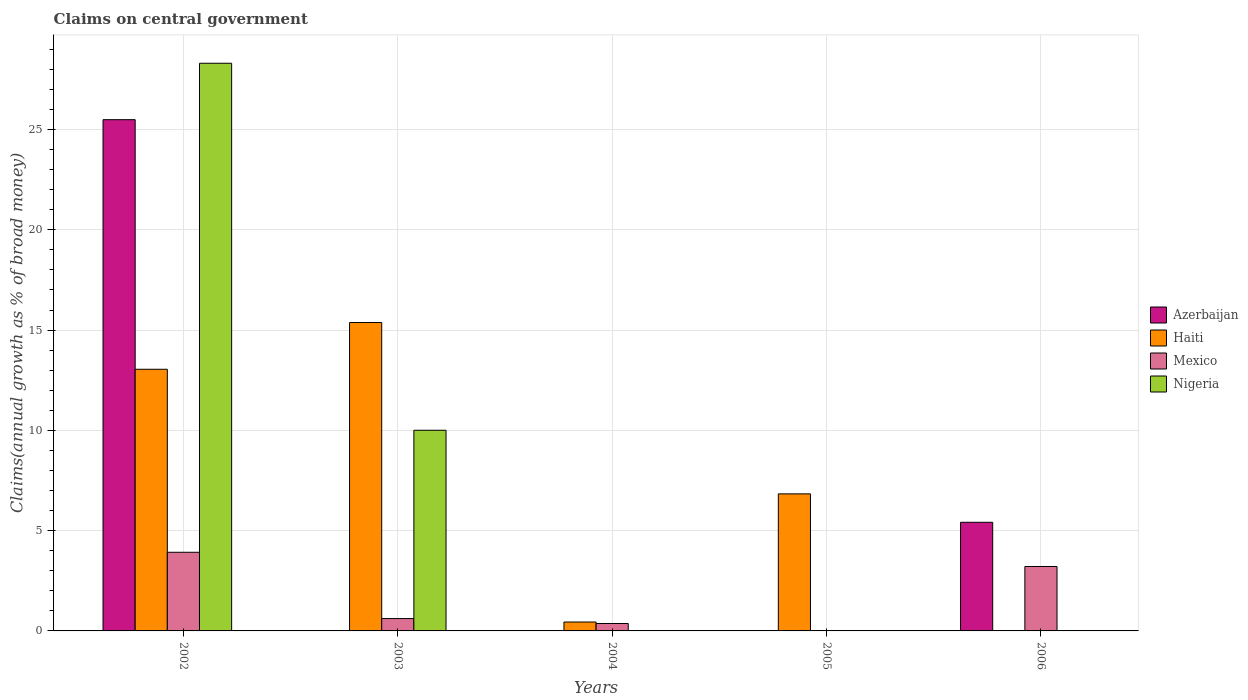Are the number of bars per tick equal to the number of legend labels?
Your response must be concise. No. Are the number of bars on each tick of the X-axis equal?
Make the answer very short. No. How many bars are there on the 1st tick from the left?
Provide a succinct answer. 4. How many bars are there on the 4th tick from the right?
Your response must be concise. 3. What is the label of the 1st group of bars from the left?
Keep it short and to the point. 2002. What is the percentage of broad money claimed on centeral government in Azerbaijan in 2002?
Provide a succinct answer. 25.49. Across all years, what is the maximum percentage of broad money claimed on centeral government in Azerbaijan?
Provide a succinct answer. 25.49. In which year was the percentage of broad money claimed on centeral government in Nigeria maximum?
Provide a succinct answer. 2002. What is the total percentage of broad money claimed on centeral government in Mexico in the graph?
Provide a succinct answer. 8.12. What is the difference between the percentage of broad money claimed on centeral government in Haiti in 2004 and that in 2005?
Ensure brevity in your answer.  -6.39. What is the average percentage of broad money claimed on centeral government in Haiti per year?
Ensure brevity in your answer.  7.14. In the year 2003, what is the difference between the percentage of broad money claimed on centeral government in Mexico and percentage of broad money claimed on centeral government in Haiti?
Provide a succinct answer. -14.76. In how many years, is the percentage of broad money claimed on centeral government in Mexico greater than 11 %?
Give a very brief answer. 0. What is the ratio of the percentage of broad money claimed on centeral government in Haiti in 2004 to that in 2005?
Offer a terse response. 0.06. Is the percentage of broad money claimed on centeral government in Haiti in 2002 less than that in 2005?
Your answer should be very brief. No. What is the difference between the highest and the second highest percentage of broad money claimed on centeral government in Haiti?
Give a very brief answer. 2.33. What is the difference between the highest and the lowest percentage of broad money claimed on centeral government in Haiti?
Your answer should be compact. 15.38. Is it the case that in every year, the sum of the percentage of broad money claimed on centeral government in Mexico and percentage of broad money claimed on centeral government in Nigeria is greater than the sum of percentage of broad money claimed on centeral government in Haiti and percentage of broad money claimed on centeral government in Azerbaijan?
Offer a terse response. No. Are all the bars in the graph horizontal?
Your response must be concise. No. How many years are there in the graph?
Your answer should be compact. 5. What is the difference between two consecutive major ticks on the Y-axis?
Your answer should be very brief. 5. Are the values on the major ticks of Y-axis written in scientific E-notation?
Ensure brevity in your answer.  No. Does the graph contain any zero values?
Make the answer very short. Yes. How are the legend labels stacked?
Ensure brevity in your answer.  Vertical. What is the title of the graph?
Your response must be concise. Claims on central government. Does "Europe(developing only)" appear as one of the legend labels in the graph?
Your answer should be compact. No. What is the label or title of the X-axis?
Your answer should be compact. Years. What is the label or title of the Y-axis?
Keep it short and to the point. Claims(annual growth as % of broad money). What is the Claims(annual growth as % of broad money) of Azerbaijan in 2002?
Provide a short and direct response. 25.49. What is the Claims(annual growth as % of broad money) of Haiti in 2002?
Offer a terse response. 13.05. What is the Claims(annual growth as % of broad money) of Mexico in 2002?
Provide a succinct answer. 3.92. What is the Claims(annual growth as % of broad money) in Nigeria in 2002?
Provide a succinct answer. 28.3. What is the Claims(annual growth as % of broad money) in Haiti in 2003?
Your answer should be compact. 15.38. What is the Claims(annual growth as % of broad money) of Mexico in 2003?
Your answer should be very brief. 0.62. What is the Claims(annual growth as % of broad money) of Nigeria in 2003?
Ensure brevity in your answer.  10.01. What is the Claims(annual growth as % of broad money) of Haiti in 2004?
Your answer should be compact. 0.44. What is the Claims(annual growth as % of broad money) of Mexico in 2004?
Keep it short and to the point. 0.37. What is the Claims(annual growth as % of broad money) in Azerbaijan in 2005?
Your answer should be very brief. 0. What is the Claims(annual growth as % of broad money) of Haiti in 2005?
Make the answer very short. 6.83. What is the Claims(annual growth as % of broad money) in Mexico in 2005?
Provide a short and direct response. 0. What is the Claims(annual growth as % of broad money) of Azerbaijan in 2006?
Offer a terse response. 5.42. What is the Claims(annual growth as % of broad money) of Haiti in 2006?
Make the answer very short. 0. What is the Claims(annual growth as % of broad money) of Mexico in 2006?
Provide a succinct answer. 3.21. Across all years, what is the maximum Claims(annual growth as % of broad money) of Azerbaijan?
Provide a short and direct response. 25.49. Across all years, what is the maximum Claims(annual growth as % of broad money) in Haiti?
Your answer should be compact. 15.38. Across all years, what is the maximum Claims(annual growth as % of broad money) in Mexico?
Keep it short and to the point. 3.92. Across all years, what is the maximum Claims(annual growth as % of broad money) in Nigeria?
Give a very brief answer. 28.3. Across all years, what is the minimum Claims(annual growth as % of broad money) of Mexico?
Your response must be concise. 0. What is the total Claims(annual growth as % of broad money) in Azerbaijan in the graph?
Make the answer very short. 30.91. What is the total Claims(annual growth as % of broad money) in Haiti in the graph?
Give a very brief answer. 35.7. What is the total Claims(annual growth as % of broad money) of Mexico in the graph?
Make the answer very short. 8.12. What is the total Claims(annual growth as % of broad money) of Nigeria in the graph?
Provide a short and direct response. 38.31. What is the difference between the Claims(annual growth as % of broad money) in Haiti in 2002 and that in 2003?
Provide a succinct answer. -2.33. What is the difference between the Claims(annual growth as % of broad money) in Mexico in 2002 and that in 2003?
Your answer should be compact. 3.31. What is the difference between the Claims(annual growth as % of broad money) in Nigeria in 2002 and that in 2003?
Your answer should be compact. 18.3. What is the difference between the Claims(annual growth as % of broad money) of Haiti in 2002 and that in 2004?
Your response must be concise. 12.6. What is the difference between the Claims(annual growth as % of broad money) in Mexico in 2002 and that in 2004?
Offer a very short reply. 3.55. What is the difference between the Claims(annual growth as % of broad money) of Haiti in 2002 and that in 2005?
Make the answer very short. 6.21. What is the difference between the Claims(annual growth as % of broad money) in Azerbaijan in 2002 and that in 2006?
Your response must be concise. 20.07. What is the difference between the Claims(annual growth as % of broad money) of Mexico in 2002 and that in 2006?
Make the answer very short. 0.71. What is the difference between the Claims(annual growth as % of broad money) of Haiti in 2003 and that in 2004?
Make the answer very short. 14.93. What is the difference between the Claims(annual growth as % of broad money) in Mexico in 2003 and that in 2004?
Offer a very short reply. 0.25. What is the difference between the Claims(annual growth as % of broad money) in Haiti in 2003 and that in 2005?
Make the answer very short. 8.54. What is the difference between the Claims(annual growth as % of broad money) in Mexico in 2003 and that in 2006?
Offer a terse response. -2.6. What is the difference between the Claims(annual growth as % of broad money) of Haiti in 2004 and that in 2005?
Your response must be concise. -6.39. What is the difference between the Claims(annual growth as % of broad money) of Mexico in 2004 and that in 2006?
Ensure brevity in your answer.  -2.84. What is the difference between the Claims(annual growth as % of broad money) in Azerbaijan in 2002 and the Claims(annual growth as % of broad money) in Haiti in 2003?
Your answer should be very brief. 10.11. What is the difference between the Claims(annual growth as % of broad money) of Azerbaijan in 2002 and the Claims(annual growth as % of broad money) of Mexico in 2003?
Provide a short and direct response. 24.87. What is the difference between the Claims(annual growth as % of broad money) of Azerbaijan in 2002 and the Claims(annual growth as % of broad money) of Nigeria in 2003?
Offer a terse response. 15.48. What is the difference between the Claims(annual growth as % of broad money) of Haiti in 2002 and the Claims(annual growth as % of broad money) of Mexico in 2003?
Ensure brevity in your answer.  12.43. What is the difference between the Claims(annual growth as % of broad money) of Haiti in 2002 and the Claims(annual growth as % of broad money) of Nigeria in 2003?
Offer a very short reply. 3.04. What is the difference between the Claims(annual growth as % of broad money) of Mexico in 2002 and the Claims(annual growth as % of broad money) of Nigeria in 2003?
Provide a short and direct response. -6.08. What is the difference between the Claims(annual growth as % of broad money) of Azerbaijan in 2002 and the Claims(annual growth as % of broad money) of Haiti in 2004?
Ensure brevity in your answer.  25.05. What is the difference between the Claims(annual growth as % of broad money) of Azerbaijan in 2002 and the Claims(annual growth as % of broad money) of Mexico in 2004?
Provide a succinct answer. 25.12. What is the difference between the Claims(annual growth as % of broad money) of Haiti in 2002 and the Claims(annual growth as % of broad money) of Mexico in 2004?
Give a very brief answer. 12.68. What is the difference between the Claims(annual growth as % of broad money) of Azerbaijan in 2002 and the Claims(annual growth as % of broad money) of Haiti in 2005?
Your answer should be compact. 18.66. What is the difference between the Claims(annual growth as % of broad money) in Azerbaijan in 2002 and the Claims(annual growth as % of broad money) in Mexico in 2006?
Your response must be concise. 22.28. What is the difference between the Claims(annual growth as % of broad money) in Haiti in 2002 and the Claims(annual growth as % of broad money) in Mexico in 2006?
Provide a succinct answer. 9.83. What is the difference between the Claims(annual growth as % of broad money) in Haiti in 2003 and the Claims(annual growth as % of broad money) in Mexico in 2004?
Provide a succinct answer. 15.01. What is the difference between the Claims(annual growth as % of broad money) of Haiti in 2003 and the Claims(annual growth as % of broad money) of Mexico in 2006?
Ensure brevity in your answer.  12.16. What is the difference between the Claims(annual growth as % of broad money) in Haiti in 2004 and the Claims(annual growth as % of broad money) in Mexico in 2006?
Give a very brief answer. -2.77. What is the difference between the Claims(annual growth as % of broad money) in Haiti in 2005 and the Claims(annual growth as % of broad money) in Mexico in 2006?
Your answer should be compact. 3.62. What is the average Claims(annual growth as % of broad money) in Azerbaijan per year?
Offer a terse response. 6.18. What is the average Claims(annual growth as % of broad money) of Haiti per year?
Keep it short and to the point. 7.14. What is the average Claims(annual growth as % of broad money) of Mexico per year?
Make the answer very short. 1.62. What is the average Claims(annual growth as % of broad money) of Nigeria per year?
Offer a very short reply. 7.66. In the year 2002, what is the difference between the Claims(annual growth as % of broad money) of Azerbaijan and Claims(annual growth as % of broad money) of Haiti?
Provide a succinct answer. 12.44. In the year 2002, what is the difference between the Claims(annual growth as % of broad money) of Azerbaijan and Claims(annual growth as % of broad money) of Mexico?
Keep it short and to the point. 21.57. In the year 2002, what is the difference between the Claims(annual growth as % of broad money) of Azerbaijan and Claims(annual growth as % of broad money) of Nigeria?
Your answer should be very brief. -2.81. In the year 2002, what is the difference between the Claims(annual growth as % of broad money) in Haiti and Claims(annual growth as % of broad money) in Mexico?
Keep it short and to the point. 9.12. In the year 2002, what is the difference between the Claims(annual growth as % of broad money) of Haiti and Claims(annual growth as % of broad money) of Nigeria?
Your response must be concise. -15.26. In the year 2002, what is the difference between the Claims(annual growth as % of broad money) in Mexico and Claims(annual growth as % of broad money) in Nigeria?
Give a very brief answer. -24.38. In the year 2003, what is the difference between the Claims(annual growth as % of broad money) in Haiti and Claims(annual growth as % of broad money) in Mexico?
Ensure brevity in your answer.  14.76. In the year 2003, what is the difference between the Claims(annual growth as % of broad money) of Haiti and Claims(annual growth as % of broad money) of Nigeria?
Your answer should be compact. 5.37. In the year 2003, what is the difference between the Claims(annual growth as % of broad money) in Mexico and Claims(annual growth as % of broad money) in Nigeria?
Provide a succinct answer. -9.39. In the year 2004, what is the difference between the Claims(annual growth as % of broad money) of Haiti and Claims(annual growth as % of broad money) of Mexico?
Keep it short and to the point. 0.07. In the year 2006, what is the difference between the Claims(annual growth as % of broad money) in Azerbaijan and Claims(annual growth as % of broad money) in Mexico?
Your response must be concise. 2.2. What is the ratio of the Claims(annual growth as % of broad money) of Haiti in 2002 to that in 2003?
Your response must be concise. 0.85. What is the ratio of the Claims(annual growth as % of broad money) in Mexico in 2002 to that in 2003?
Offer a terse response. 6.37. What is the ratio of the Claims(annual growth as % of broad money) of Nigeria in 2002 to that in 2003?
Offer a terse response. 2.83. What is the ratio of the Claims(annual growth as % of broad money) in Haiti in 2002 to that in 2004?
Your response must be concise. 29.4. What is the ratio of the Claims(annual growth as % of broad money) in Mexico in 2002 to that in 2004?
Make the answer very short. 10.6. What is the ratio of the Claims(annual growth as % of broad money) in Haiti in 2002 to that in 2005?
Offer a very short reply. 1.91. What is the ratio of the Claims(annual growth as % of broad money) in Azerbaijan in 2002 to that in 2006?
Provide a succinct answer. 4.71. What is the ratio of the Claims(annual growth as % of broad money) of Mexico in 2002 to that in 2006?
Keep it short and to the point. 1.22. What is the ratio of the Claims(annual growth as % of broad money) in Haiti in 2003 to that in 2004?
Your answer should be very brief. 34.65. What is the ratio of the Claims(annual growth as % of broad money) of Mexico in 2003 to that in 2004?
Your response must be concise. 1.66. What is the ratio of the Claims(annual growth as % of broad money) in Haiti in 2003 to that in 2005?
Your response must be concise. 2.25. What is the ratio of the Claims(annual growth as % of broad money) of Mexico in 2003 to that in 2006?
Give a very brief answer. 0.19. What is the ratio of the Claims(annual growth as % of broad money) of Haiti in 2004 to that in 2005?
Provide a succinct answer. 0.06. What is the ratio of the Claims(annual growth as % of broad money) of Mexico in 2004 to that in 2006?
Provide a short and direct response. 0.12. What is the difference between the highest and the second highest Claims(annual growth as % of broad money) of Haiti?
Provide a short and direct response. 2.33. What is the difference between the highest and the second highest Claims(annual growth as % of broad money) in Mexico?
Ensure brevity in your answer.  0.71. What is the difference between the highest and the lowest Claims(annual growth as % of broad money) in Azerbaijan?
Your response must be concise. 25.49. What is the difference between the highest and the lowest Claims(annual growth as % of broad money) of Haiti?
Make the answer very short. 15.38. What is the difference between the highest and the lowest Claims(annual growth as % of broad money) of Mexico?
Your answer should be very brief. 3.92. What is the difference between the highest and the lowest Claims(annual growth as % of broad money) in Nigeria?
Your response must be concise. 28.3. 